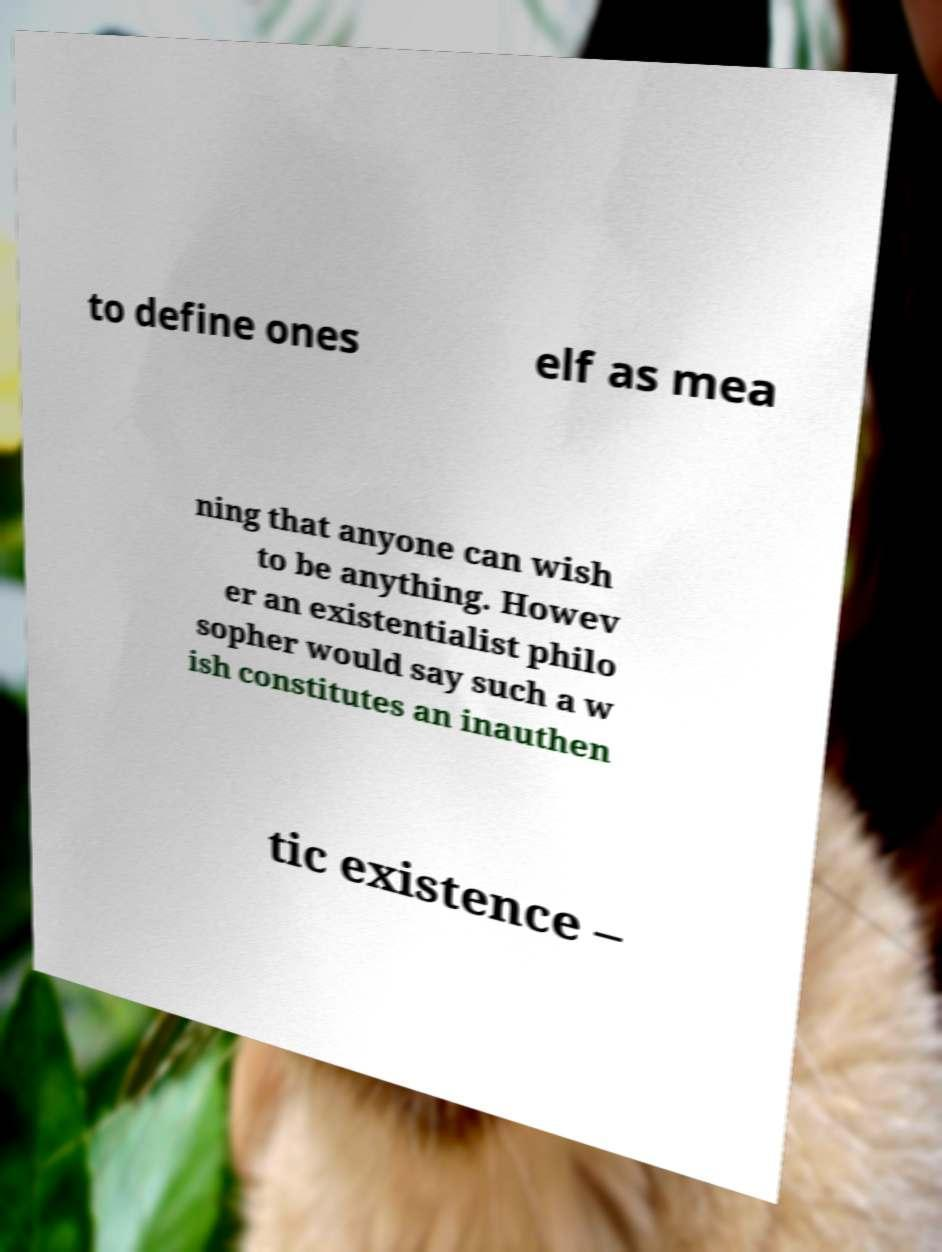For documentation purposes, I need the text within this image transcribed. Could you provide that? to define ones elf as mea ning that anyone can wish to be anything. Howev er an existentialist philo sopher would say such a w ish constitutes an inauthen tic existence – 